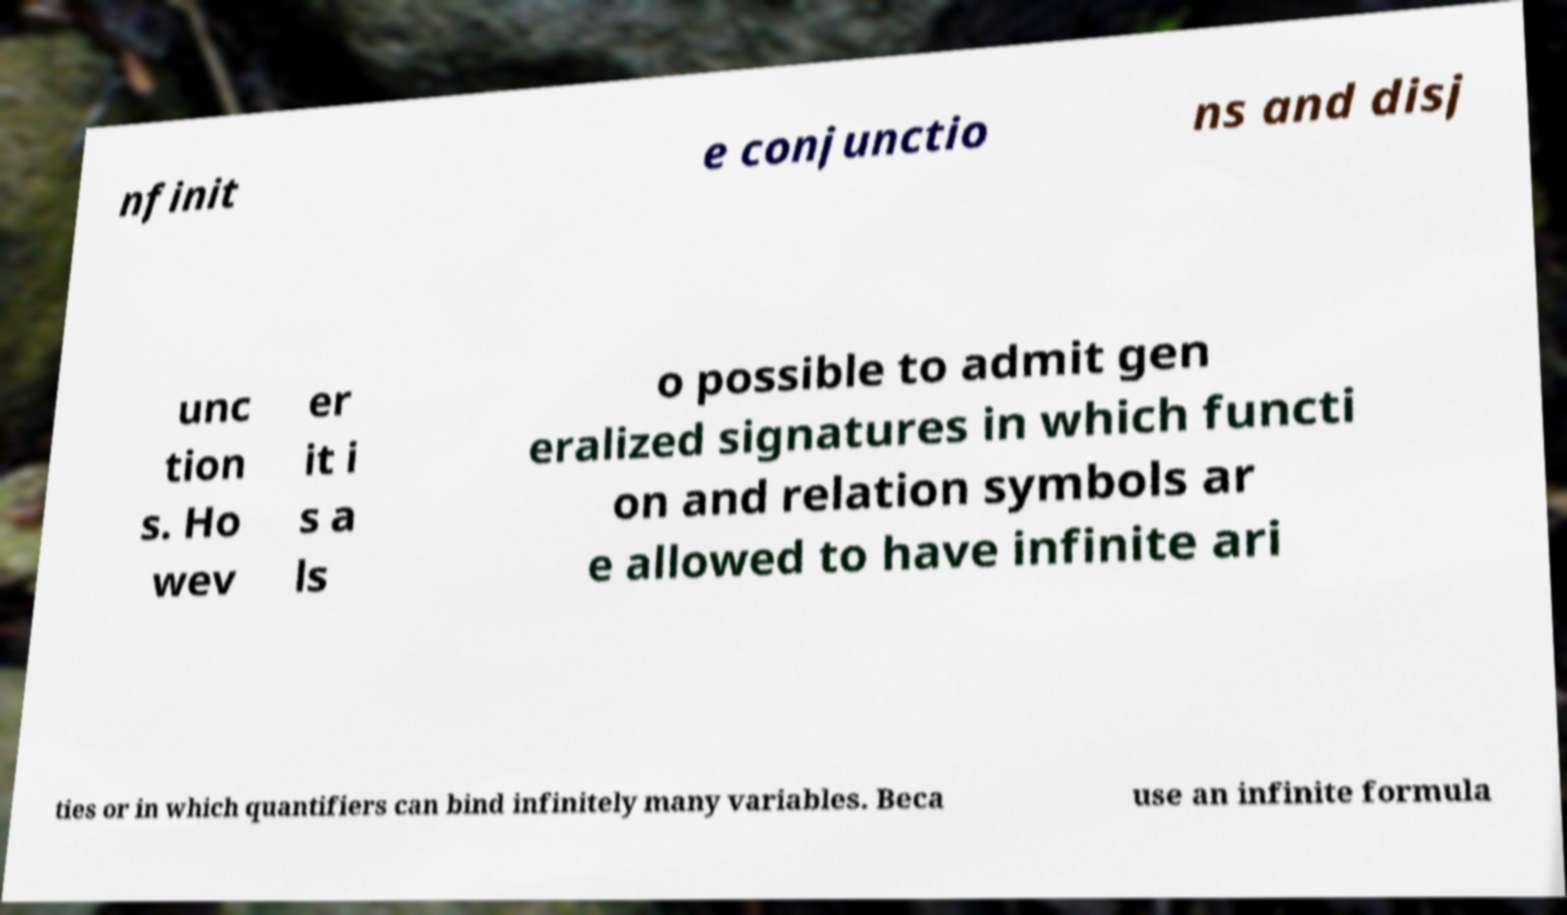Could you extract and type out the text from this image? nfinit e conjunctio ns and disj unc tion s. Ho wev er it i s a ls o possible to admit gen eralized signatures in which functi on and relation symbols ar e allowed to have infinite ari ties or in which quantifiers can bind infinitely many variables. Beca use an infinite formula 